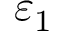Convert formula to latex. <formula><loc_0><loc_0><loc_500><loc_500>\varepsilon _ { 1 }</formula> 